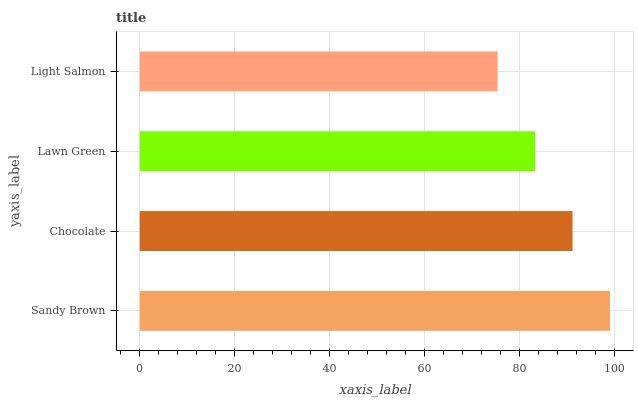Is Light Salmon the minimum?
Answer yes or no. Yes. Is Sandy Brown the maximum?
Answer yes or no. Yes. Is Chocolate the minimum?
Answer yes or no. No. Is Chocolate the maximum?
Answer yes or no. No. Is Sandy Brown greater than Chocolate?
Answer yes or no. Yes. Is Chocolate less than Sandy Brown?
Answer yes or no. Yes. Is Chocolate greater than Sandy Brown?
Answer yes or no. No. Is Sandy Brown less than Chocolate?
Answer yes or no. No. Is Chocolate the high median?
Answer yes or no. Yes. Is Lawn Green the low median?
Answer yes or no. Yes. Is Lawn Green the high median?
Answer yes or no. No. Is Chocolate the low median?
Answer yes or no. No. 